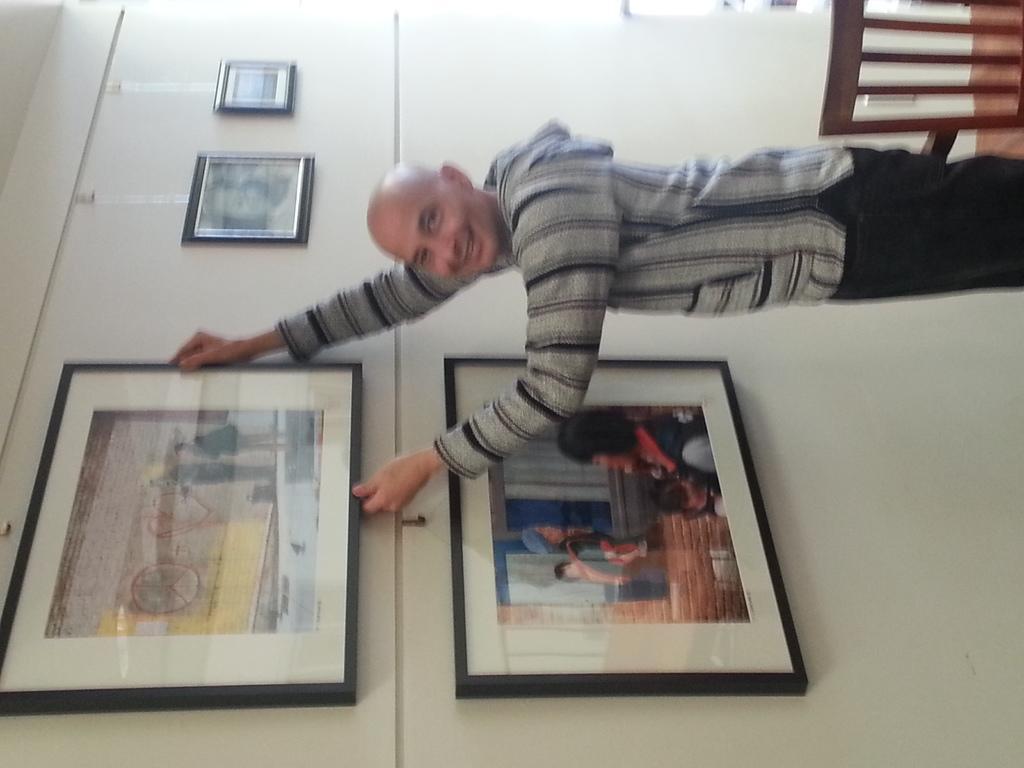Could you give a brief overview of what you see in this image? In this image I can see a man is standing. I can also see the wall and on it I can see few frames. On the top right corner I can see a chair. 